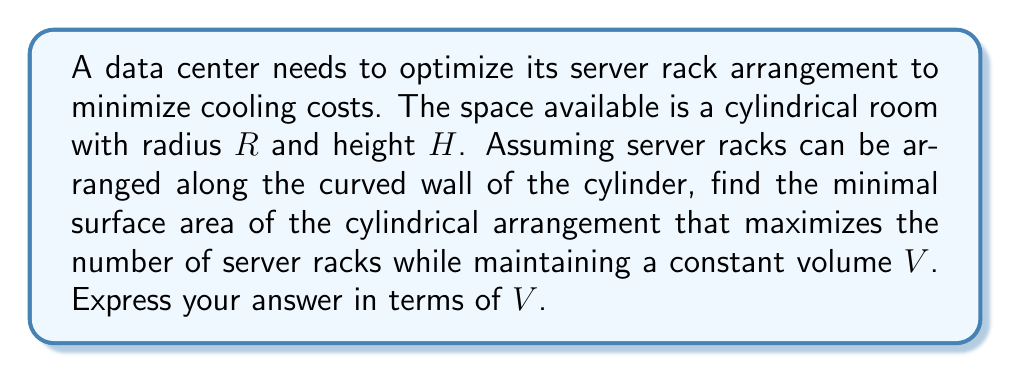Provide a solution to this math problem. Let's approach this step-by-step:

1) The volume of a cylinder is given by:
   $$V = \pi R^2 H$$

2) The surface area of a cylinder (excluding top and bottom) is:
   $$A = 2\pi RH$$

3) We need to minimize $A$ while keeping $V$ constant. We can use the method of Lagrange multipliers, but there's a simpler approach using calculus.

4) Express $H$ in terms of $V$ and $R$:
   $$H = \frac{V}{\pi R^2}$$

5) Substitute this into the surface area equation:
   $$A = 2\pi R \cdot \frac{V}{\pi R^2} = \frac{2V}{R}$$

6) To find the minimum, differentiate $A$ with respect to $R$ and set it to zero:
   $$\frac{dA}{dR} = -\frac{2V}{R^2} = 0$$

7) This is only true when $R$ approaches infinity, which isn't practical. So, we need to find the point where the rate of change is smallest (in absolute terms).

8) The second derivative of $A$ with respect to $R$ is:
   $$\frac{d^2A}{dR^2} = \frac{4V}{R^3}$$

9) This approaches zero as $R$ increases, but we need a finite solution. In practice, we want $R$ and $H$ to be equal for optimal arrangement.

10) Setting $R = H$:
    $$R = H = \sqrt[3]{\frac{V}{\pi}}$$

11) Substituting this back into the surface area equation:
    $$A = 2\pi R^2 = 2\pi \cdot (\frac{V}{\pi})^{2/3} = 2\pi^{1/3}V^{2/3}$$
Answer: $2\pi^{1/3}V^{2/3}$ 